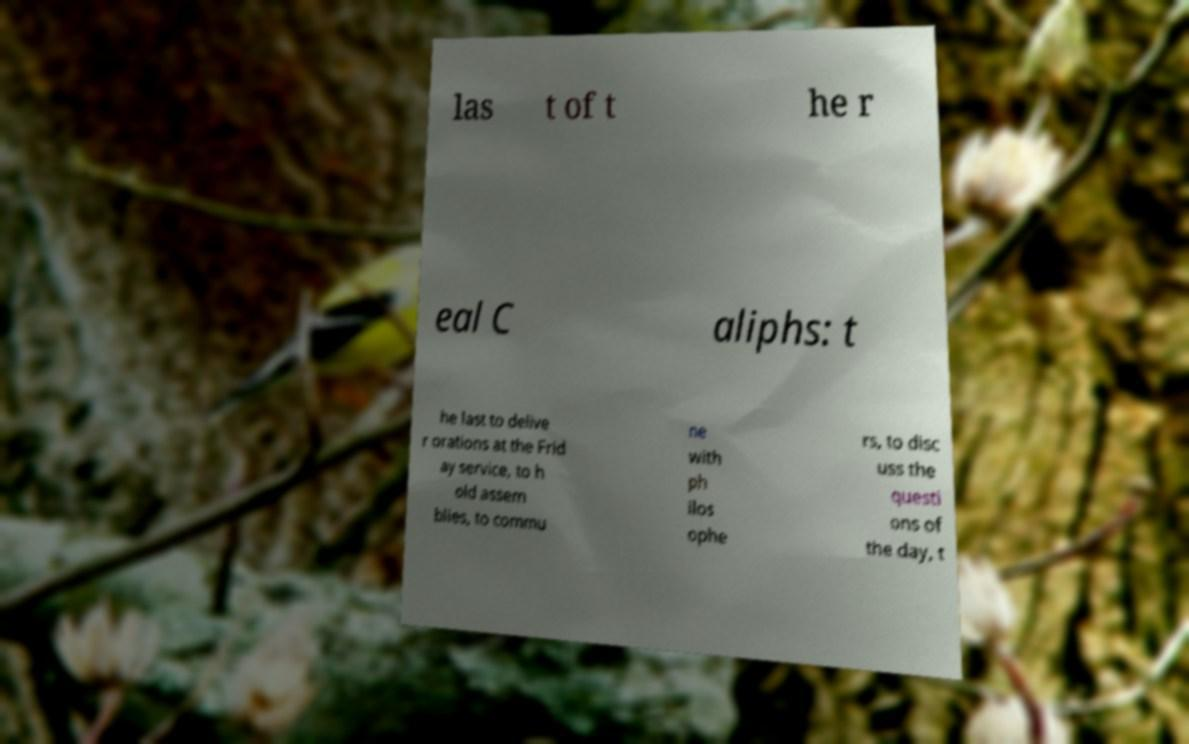Please identify and transcribe the text found in this image. las t of t he r eal C aliphs: t he last to delive r orations at the Frid ay service, to h old assem blies, to commu ne with ph ilos ophe rs, to disc uss the questi ons of the day, t 